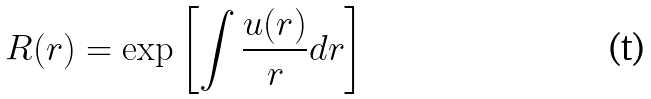<formula> <loc_0><loc_0><loc_500><loc_500>R ( r ) = \exp \left [ \int \frac { u ( r ) } { r } d r \right ]</formula> 